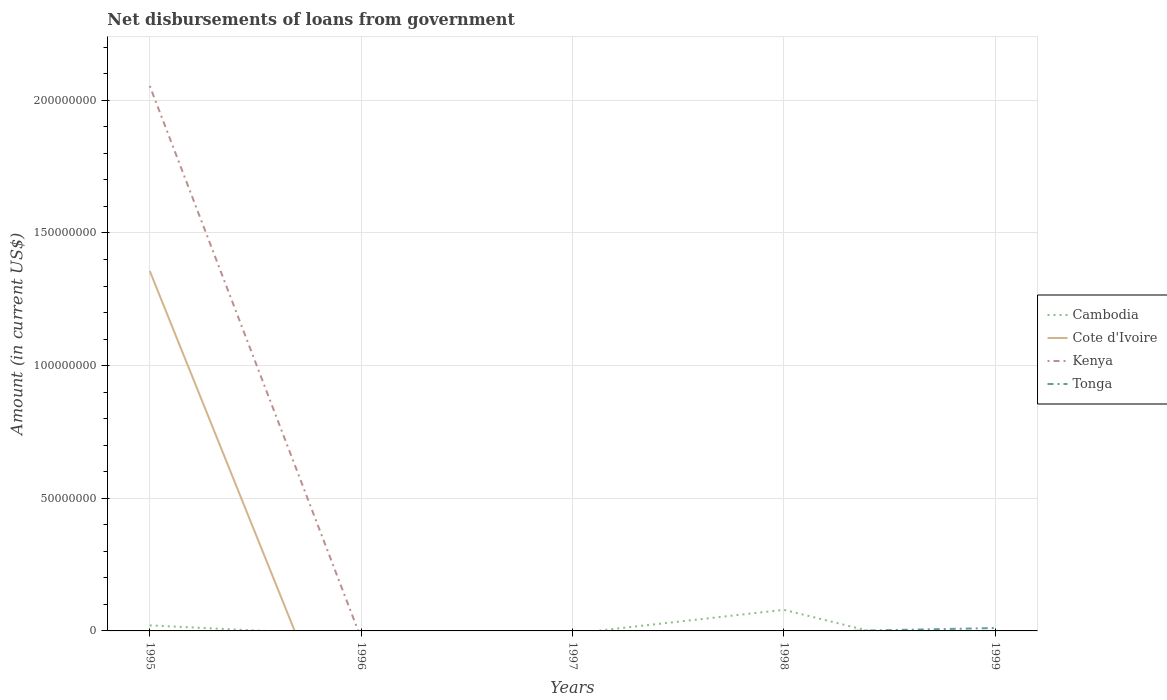Does the line corresponding to Cote d'Ivoire intersect with the line corresponding to Kenya?
Your response must be concise. Yes. Across all years, what is the maximum amount of loan disbursed from government in Cote d'Ivoire?
Keep it short and to the point. 0. What is the difference between the highest and the second highest amount of loan disbursed from government in Kenya?
Provide a succinct answer. 2.05e+08. How many lines are there?
Keep it short and to the point. 4. What is the difference between two consecutive major ticks on the Y-axis?
Your response must be concise. 5.00e+07. Does the graph contain any zero values?
Provide a short and direct response. Yes. Does the graph contain grids?
Your response must be concise. Yes. Where does the legend appear in the graph?
Provide a short and direct response. Center right. What is the title of the graph?
Ensure brevity in your answer.  Net disbursements of loans from government. What is the label or title of the Y-axis?
Provide a short and direct response. Amount (in current US$). What is the Amount (in current US$) in Cambodia in 1995?
Ensure brevity in your answer.  2.08e+06. What is the Amount (in current US$) of Cote d'Ivoire in 1995?
Provide a short and direct response. 1.36e+08. What is the Amount (in current US$) in Kenya in 1995?
Provide a short and direct response. 2.05e+08. What is the Amount (in current US$) in Tonga in 1996?
Give a very brief answer. 0. What is the Amount (in current US$) in Cote d'Ivoire in 1997?
Make the answer very short. 0. What is the Amount (in current US$) of Kenya in 1997?
Give a very brief answer. 0. What is the Amount (in current US$) of Tonga in 1997?
Your answer should be compact. 0. What is the Amount (in current US$) of Cambodia in 1998?
Offer a very short reply. 7.95e+06. What is the Amount (in current US$) in Cote d'Ivoire in 1998?
Ensure brevity in your answer.  0. What is the Amount (in current US$) in Tonga in 1998?
Ensure brevity in your answer.  0. What is the Amount (in current US$) in Cambodia in 1999?
Offer a terse response. 0. What is the Amount (in current US$) of Kenya in 1999?
Your answer should be compact. 0. What is the Amount (in current US$) of Tonga in 1999?
Your answer should be very brief. 1.09e+06. Across all years, what is the maximum Amount (in current US$) of Cambodia?
Keep it short and to the point. 7.95e+06. Across all years, what is the maximum Amount (in current US$) of Cote d'Ivoire?
Provide a succinct answer. 1.36e+08. Across all years, what is the maximum Amount (in current US$) of Kenya?
Your answer should be very brief. 2.05e+08. Across all years, what is the maximum Amount (in current US$) in Tonga?
Your answer should be very brief. 1.09e+06. Across all years, what is the minimum Amount (in current US$) in Tonga?
Ensure brevity in your answer.  0. What is the total Amount (in current US$) of Cambodia in the graph?
Provide a succinct answer. 1.00e+07. What is the total Amount (in current US$) of Cote d'Ivoire in the graph?
Your answer should be compact. 1.36e+08. What is the total Amount (in current US$) in Kenya in the graph?
Give a very brief answer. 2.05e+08. What is the total Amount (in current US$) of Tonga in the graph?
Your response must be concise. 1.09e+06. What is the difference between the Amount (in current US$) of Cambodia in 1995 and that in 1998?
Your answer should be compact. -5.88e+06. What is the difference between the Amount (in current US$) in Cambodia in 1995 and the Amount (in current US$) in Tonga in 1999?
Keep it short and to the point. 9.85e+05. What is the difference between the Amount (in current US$) in Cote d'Ivoire in 1995 and the Amount (in current US$) in Tonga in 1999?
Offer a very short reply. 1.35e+08. What is the difference between the Amount (in current US$) of Kenya in 1995 and the Amount (in current US$) of Tonga in 1999?
Make the answer very short. 2.04e+08. What is the difference between the Amount (in current US$) of Cambodia in 1998 and the Amount (in current US$) of Tonga in 1999?
Provide a succinct answer. 6.86e+06. What is the average Amount (in current US$) in Cambodia per year?
Give a very brief answer. 2.01e+06. What is the average Amount (in current US$) in Cote d'Ivoire per year?
Provide a succinct answer. 2.71e+07. What is the average Amount (in current US$) of Kenya per year?
Your answer should be very brief. 4.11e+07. What is the average Amount (in current US$) in Tonga per year?
Offer a very short reply. 2.18e+05. In the year 1995, what is the difference between the Amount (in current US$) of Cambodia and Amount (in current US$) of Cote d'Ivoire?
Keep it short and to the point. -1.34e+08. In the year 1995, what is the difference between the Amount (in current US$) of Cambodia and Amount (in current US$) of Kenya?
Offer a terse response. -2.03e+08. In the year 1995, what is the difference between the Amount (in current US$) in Cote d'Ivoire and Amount (in current US$) in Kenya?
Keep it short and to the point. -6.98e+07. What is the ratio of the Amount (in current US$) in Cambodia in 1995 to that in 1998?
Your answer should be compact. 0.26. What is the difference between the highest and the lowest Amount (in current US$) of Cambodia?
Keep it short and to the point. 7.95e+06. What is the difference between the highest and the lowest Amount (in current US$) of Cote d'Ivoire?
Your answer should be very brief. 1.36e+08. What is the difference between the highest and the lowest Amount (in current US$) of Kenya?
Your response must be concise. 2.05e+08. What is the difference between the highest and the lowest Amount (in current US$) of Tonga?
Give a very brief answer. 1.09e+06. 